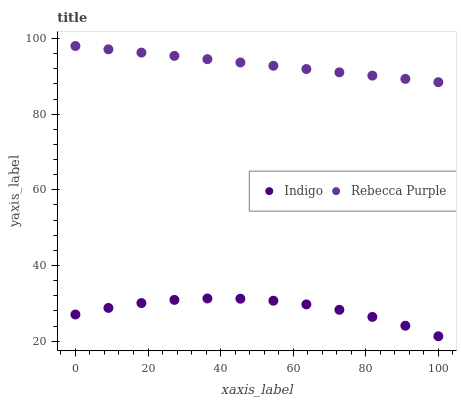Does Indigo have the minimum area under the curve?
Answer yes or no. Yes. Does Rebecca Purple have the maximum area under the curve?
Answer yes or no. Yes. Does Rebecca Purple have the minimum area under the curve?
Answer yes or no. No. Is Rebecca Purple the smoothest?
Answer yes or no. Yes. Is Indigo the roughest?
Answer yes or no. Yes. Is Rebecca Purple the roughest?
Answer yes or no. No. Does Indigo have the lowest value?
Answer yes or no. Yes. Does Rebecca Purple have the lowest value?
Answer yes or no. No. Does Rebecca Purple have the highest value?
Answer yes or no. Yes. Is Indigo less than Rebecca Purple?
Answer yes or no. Yes. Is Rebecca Purple greater than Indigo?
Answer yes or no. Yes. Does Indigo intersect Rebecca Purple?
Answer yes or no. No. 